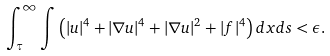Convert formula to latex. <formula><loc_0><loc_0><loc_500><loc_500>\int ^ { \infty } _ { \tau } \int \left ( | u | ^ { 4 } + | \nabla u | ^ { 4 } + | \nabla u | ^ { 2 } + | f | ^ { 4 } \right ) d x d s < \epsilon .</formula> 